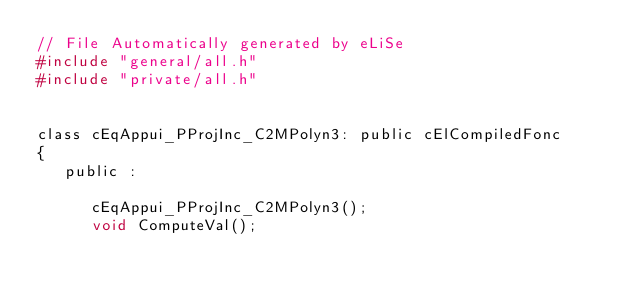<code> <loc_0><loc_0><loc_500><loc_500><_C_>// File Automatically generated by eLiSe
#include "general/all.h"
#include "private/all.h"


class cEqAppui_PProjInc_C2MPolyn3: public cElCompiledFonc
{
   public :

      cEqAppui_PProjInc_C2MPolyn3();
      void ComputeVal();</code> 